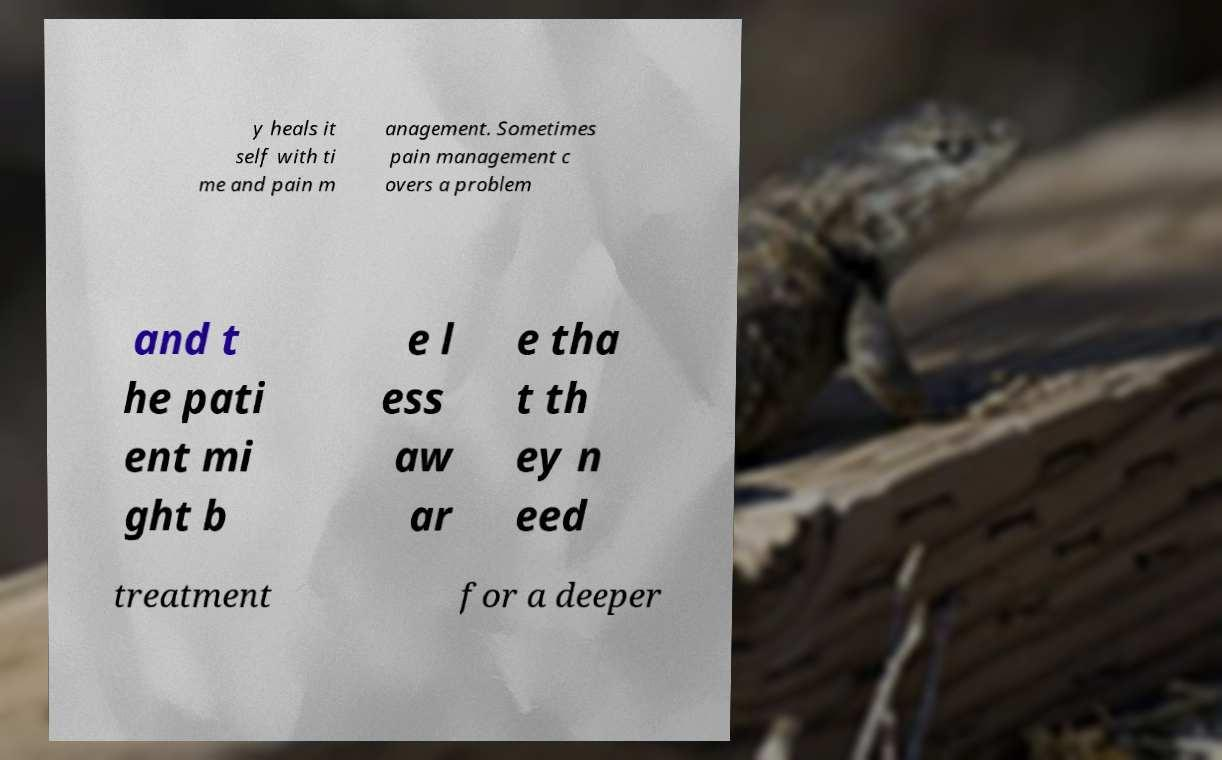Please read and relay the text visible in this image. What does it say? y heals it self with ti me and pain m anagement. Sometimes pain management c overs a problem and t he pati ent mi ght b e l ess aw ar e tha t th ey n eed treatment for a deeper 